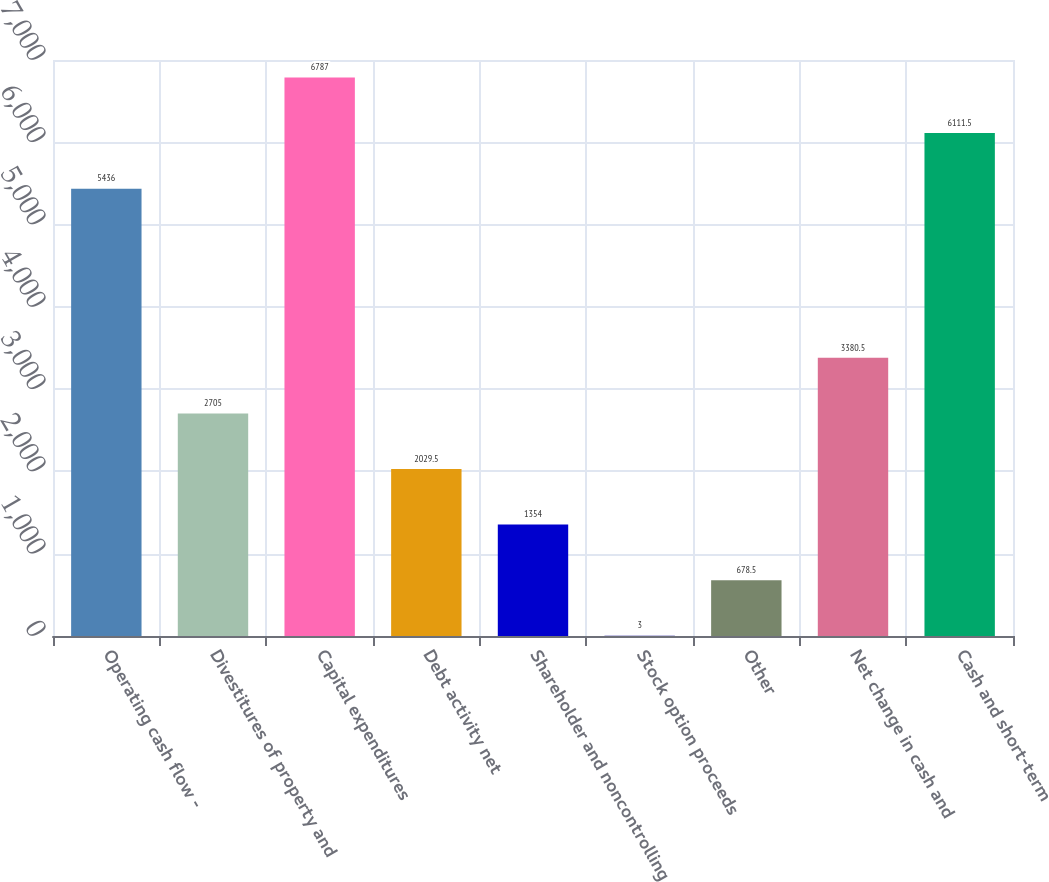Convert chart. <chart><loc_0><loc_0><loc_500><loc_500><bar_chart><fcel>Operating cash flow -<fcel>Divestitures of property and<fcel>Capital expenditures<fcel>Debt activity net<fcel>Shareholder and noncontrolling<fcel>Stock option proceeds<fcel>Other<fcel>Net change in cash and<fcel>Cash and short-term<nl><fcel>5436<fcel>2705<fcel>6787<fcel>2029.5<fcel>1354<fcel>3<fcel>678.5<fcel>3380.5<fcel>6111.5<nl></chart> 